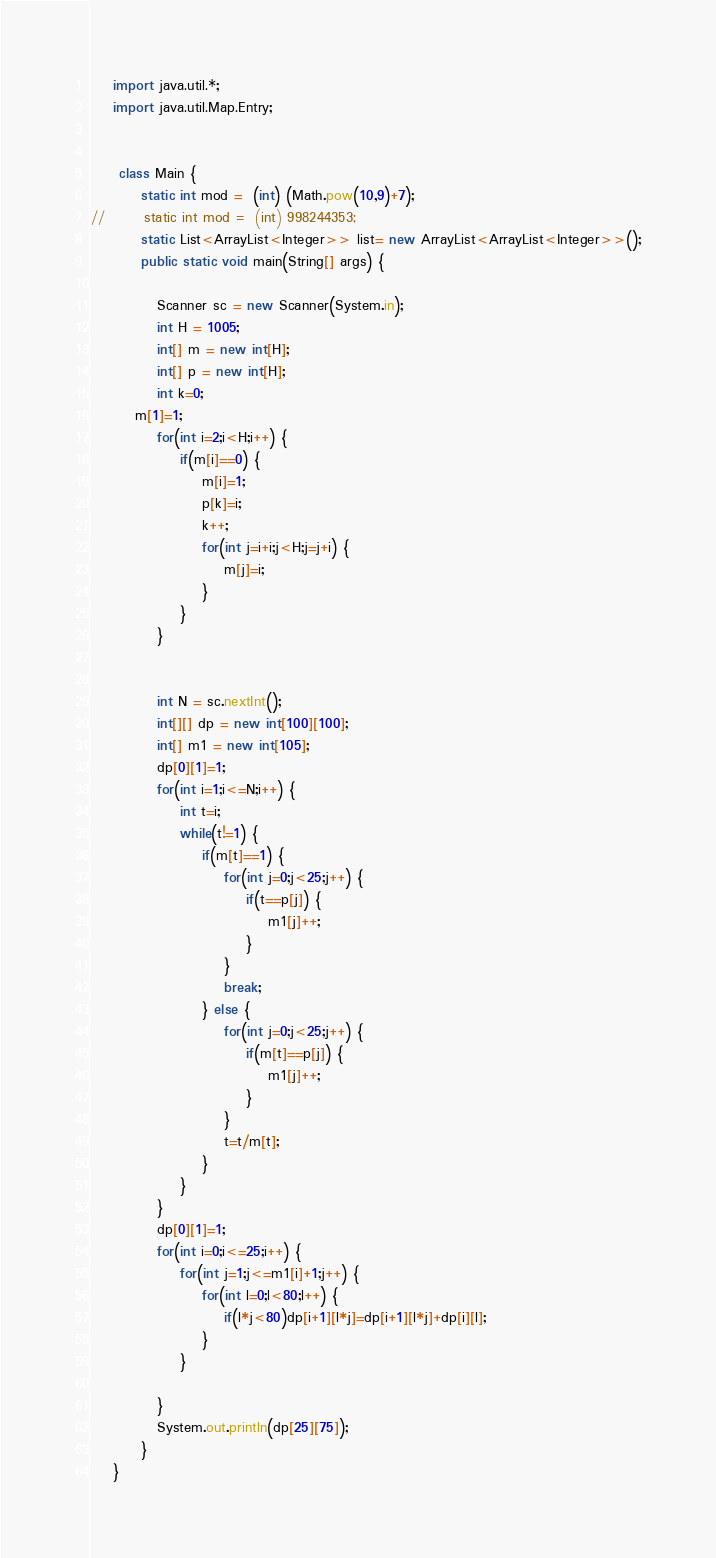<code> <loc_0><loc_0><loc_500><loc_500><_Java_>	import java.util.*;
	import java.util.Map.Entry;
	 
	 
	 class Main {
		 static int mod =  (int) (Math.pow(10,9)+7);
//		 static int mod =  (int) 998244353;
		 static List<ArrayList<Integer>> list= new ArrayList<ArrayList<Integer>>();
		 public static void main(String[] args) {
	    	
	        Scanner sc = new Scanner(System.in);
	        int H = 1005;
	        int[] m = new int[H];
	        int[] p = new int[H];
	        int k=0;
		m[1]=1;
	        for(int i=2;i<H;i++) {
	        	if(m[i]==0) {
	        		m[i]=1;
	        		p[k]=i;
	        		k++;
	        		for(int j=i+i;j<H;j=j+i) {
	        			m[j]=i;
	        		}
	        	}
	        }	        

	        
	        int N = sc.nextInt();
	        int[][] dp = new int[100][100];
	        int[] m1 = new int[105];
	        dp[0][1]=1;
	        for(int i=1;i<=N;i++) {
	        	int t=i;
	        	while(t!=1) {
        			if(m[t]==1) {
    	        		for(int j=0;j<25;j++) {
    	        			if(t==p[j]) {
    	        				m1[j]++;
    	        			}
    	        		}        				
        				break;
        			} else {
    	        		for(int j=0;j<25;j++) {
    	        			if(m[t]==p[j]) {
    	        				m1[j]++;
    	        			}
    	        		}
    	        		t=t/m[t];        				
        			}
	        	}
	        }
	        dp[0][1]=1;
	        for(int i=0;i<=25;i++) {
	        	for(int j=1;j<=m1[i]+1;j++) {
	        		for(int l=0;l<80;l++) {
	        			if(l*j<80)dp[i+1][l*j]=dp[i+1][l*j]+dp[i][l];	   
	        		}     		
	        	}
	        	
	        }
	        System.out.println(dp[25][75]);
		 }
	}</code> 